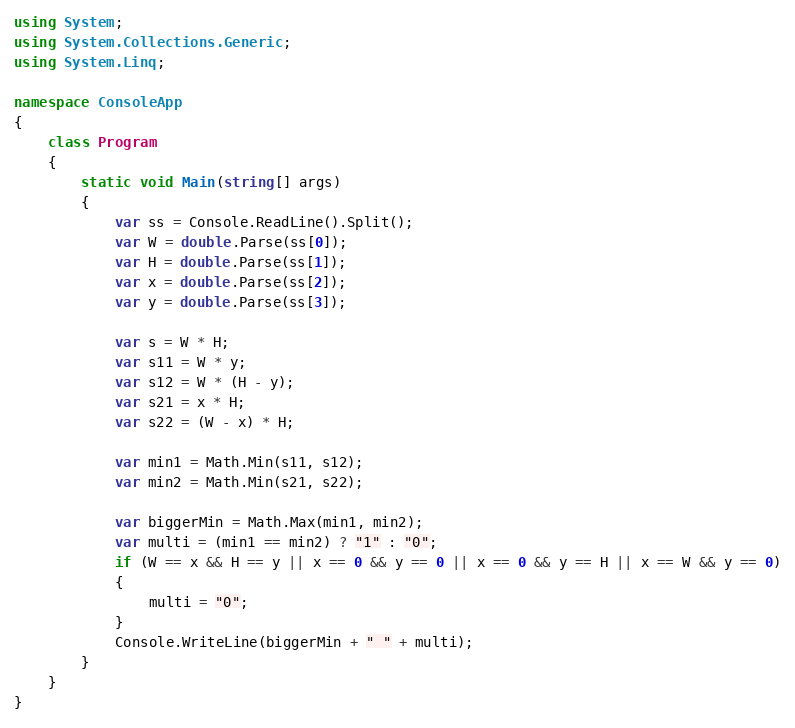<code> <loc_0><loc_0><loc_500><loc_500><_C#_>using System;
using System.Collections.Generic;
using System.Linq;

namespace ConsoleApp
{
    class Program
    {
        static void Main(string[] args)
        {
            var ss = Console.ReadLine().Split();
            var W = double.Parse(ss[0]);
            var H = double.Parse(ss[1]);
            var x = double.Parse(ss[2]);
            var y = double.Parse(ss[3]);

            var s = W * H;
            var s11 = W * y;
            var s12 = W * (H - y);
            var s21 = x * H;
            var s22 = (W - x) * H;

            var min1 = Math.Min(s11, s12);
            var min2 = Math.Min(s21, s22);

            var biggerMin = Math.Max(min1, min2);
            var multi = (min1 == min2) ? "1" : "0";
            if (W == x && H == y || x == 0 && y == 0 || x == 0 && y == H || x == W && y == 0)
            {
                multi = "0";
            }
            Console.WriteLine(biggerMin + " " + multi);
        }
    }
}</code> 